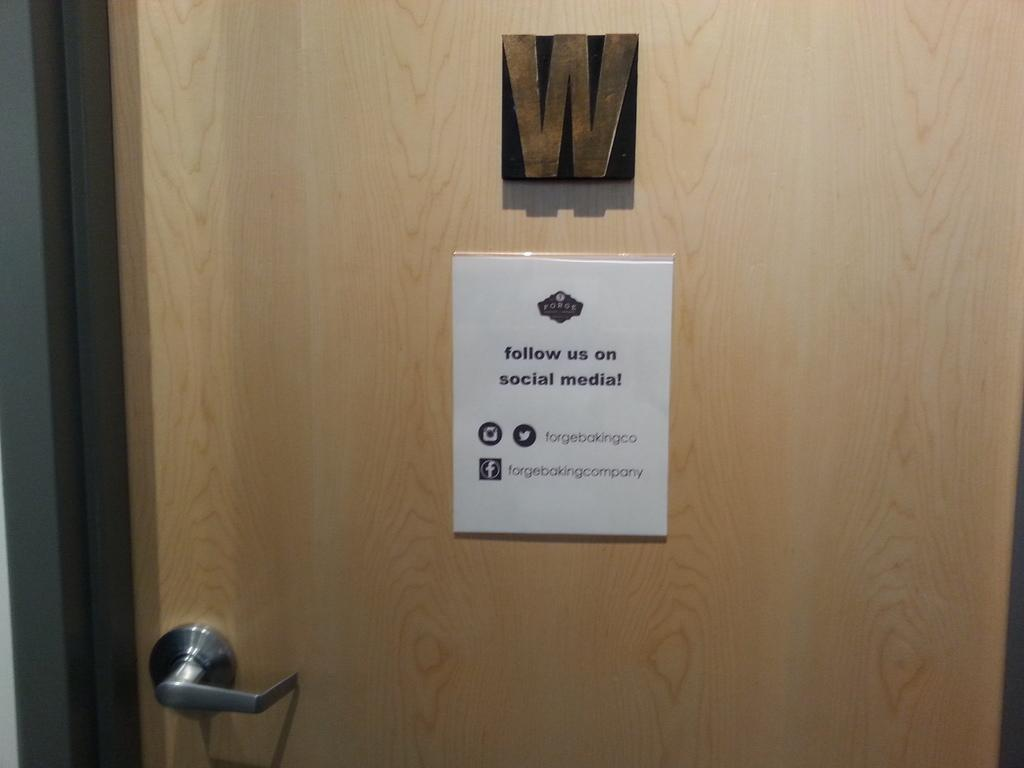What is a prominent feature in the image? There is a door in the image. How is the door connected to the wall? The door is attached to a wall. What can be used to open or close the door? The door has a handle. What is hanging on the door? A poster and a board are attached to the door. What type of jewel can be seen hanging from the man's neck in the image? There is no man or jewel present in the image; it only features a door with a handle, a poster, and a board attached to it. 